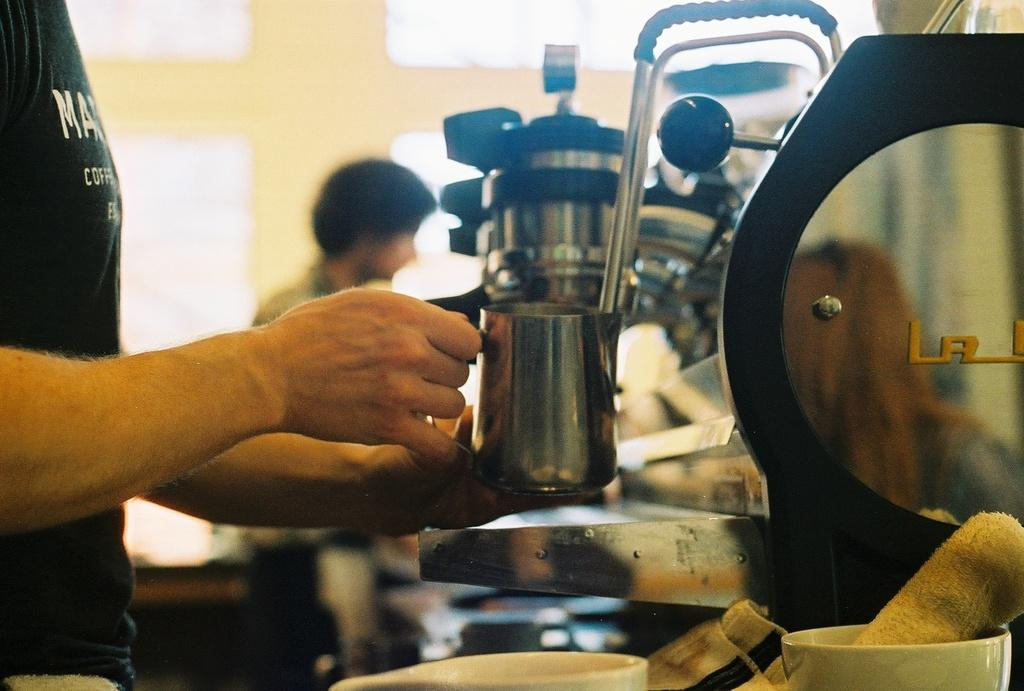Who is present in the image? There is a person in the image. What is the person holding in the image? The person is holding a cup. Where is the cup located in relation to the person? The cup is in the person's hand. What is located beside the cup? There is a machine beside the cup. How is the background of the machine depicted in the image? The background of the machine is blurred. What type of magic is being performed with the cup in the image? There is no magic being performed in the image; the person is simply holding a cup. 